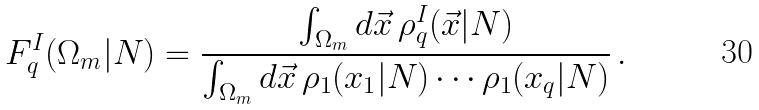<formula> <loc_0><loc_0><loc_500><loc_500>F _ { q } ^ { I } ( \Omega _ { m } | N ) = { \frac { \int _ { \Omega _ { m } } d \vec { x } \, \rho _ { q } ^ { I } ( \vec { x } | N ) } { \int _ { \Omega _ { m } } d \vec { x } \, \rho _ { 1 } ( x _ { 1 } | N ) \cdots \rho _ { 1 } ( x _ { q } | N ) } } \, .</formula> 